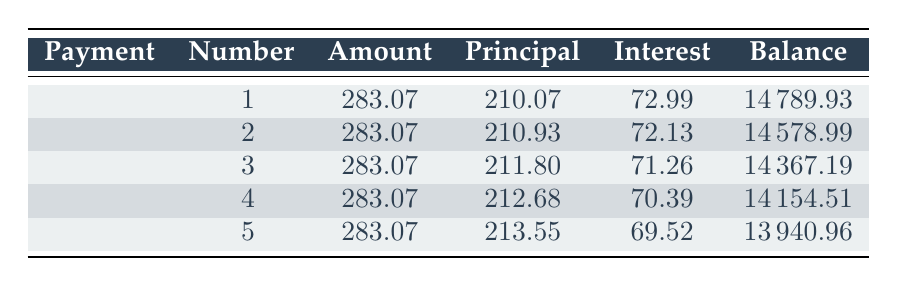What is the total cost of the stage lighting and sound systems? The total cost of the equipment is provided directly in the data, which states the total cost is 15,000.
Answer: 15000 What is the payment amount for the first installment? The payment amount for the first installment is specified in the first row of the table, which shows a payment amount of 283.07.
Answer: 283.07 How much interest was paid in the second payment? The interest payment for the second installment is listed in the second row of the table, which shows an interest payment of 72.13.
Answer: 72.13 What is the principal payment for the third installment? The principal payment for the third installment is given in the third row of the table, where the principal payment is indicated as 211.80.
Answer: 211.80 Is the remaining balance after the fifth payment less than 14,000? The remaining balance after the fifth payment is listed in the fifth row, which shows a remaining balance of 13,940.96. Since this is less than 14,000, the answer is yes.
Answer: Yes What is the average principal payment over the first five installments? The total principal payments for the first five installments are calculated as follows: (210.07 + 210.93 + 211.80 + 212.68 + 213.55) = 1,067.03. To find the average, divide by 5: 1,067.03 / 5 = 213.41.
Answer: 213.41 How much total interest will be paid over the first five payments? The total interest paid over the first five payments is calculated by summing the interest payments: (72.99 + 72.13 + 71.26 + 70.39 + 69.52) = 356.29.
Answer: 356.29 What is the difference in the principal payment between the first and the fifth payments? The principal payment for the first installment is 210.07 and for the fifth installment is 213.55. To find the difference, calculate 213.55 – 210.07 = 3.48.
Answer: 3.48 If the loan were to end after the first three payments, what would the remaining balance be? After the third payment, the remaining balance is recorded in the third row, which indicates a remaining balance of 14,367.19 after the third payment.
Answer: 14367.19 